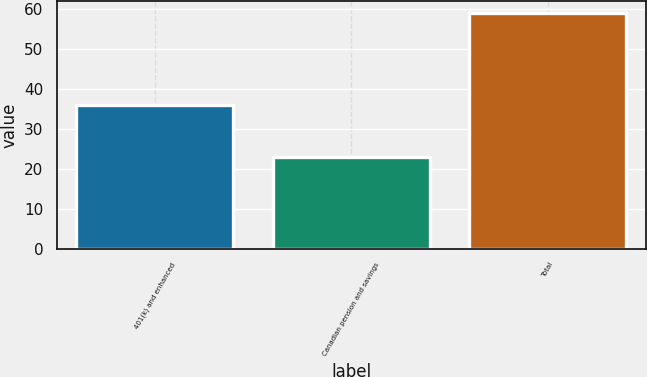Convert chart to OTSL. <chart><loc_0><loc_0><loc_500><loc_500><bar_chart><fcel>401(k) and enhanced<fcel>Canadian pension and savings<fcel>Total<nl><fcel>36<fcel>23<fcel>59<nl></chart> 